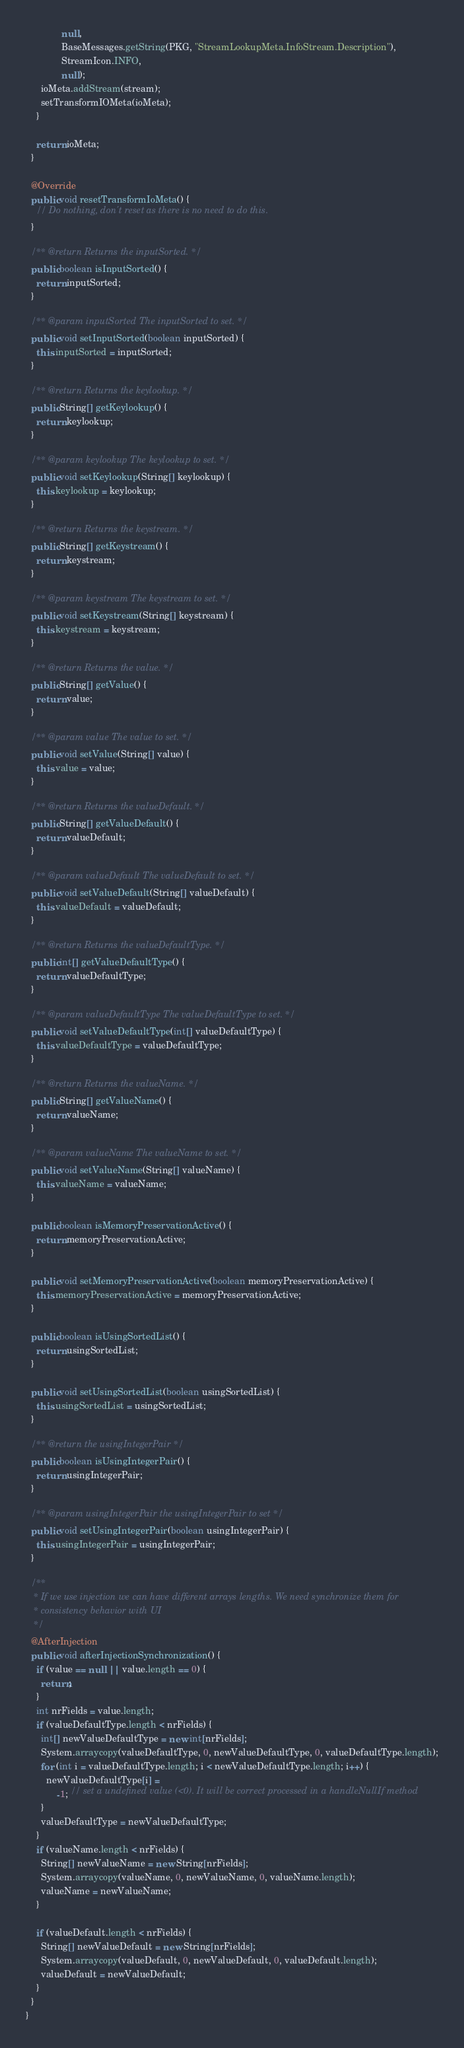<code> <loc_0><loc_0><loc_500><loc_500><_Java_>              null,
              BaseMessages.getString(PKG, "StreamLookupMeta.InfoStream.Description"),
              StreamIcon.INFO,
              null);
      ioMeta.addStream(stream);
      setTransformIOMeta(ioMeta);
    }

    return ioMeta;
  }

  @Override
  public void resetTransformIoMeta() {
    // Do nothing, don't reset as there is no need to do this.
  }

  /** @return Returns the inputSorted. */
  public boolean isInputSorted() {
    return inputSorted;
  }

  /** @param inputSorted The inputSorted to set. */
  public void setInputSorted(boolean inputSorted) {
    this.inputSorted = inputSorted;
  }

  /** @return Returns the keylookup. */
  public String[] getKeylookup() {
    return keylookup;
  }

  /** @param keylookup The keylookup to set. */
  public void setKeylookup(String[] keylookup) {
    this.keylookup = keylookup;
  }

  /** @return Returns the keystream. */
  public String[] getKeystream() {
    return keystream;
  }

  /** @param keystream The keystream to set. */
  public void setKeystream(String[] keystream) {
    this.keystream = keystream;
  }

  /** @return Returns the value. */
  public String[] getValue() {
    return value;
  }

  /** @param value The value to set. */
  public void setValue(String[] value) {
    this.value = value;
  }

  /** @return Returns the valueDefault. */
  public String[] getValueDefault() {
    return valueDefault;
  }

  /** @param valueDefault The valueDefault to set. */
  public void setValueDefault(String[] valueDefault) {
    this.valueDefault = valueDefault;
  }

  /** @return Returns the valueDefaultType. */
  public int[] getValueDefaultType() {
    return valueDefaultType;
  }

  /** @param valueDefaultType The valueDefaultType to set. */
  public void setValueDefaultType(int[] valueDefaultType) {
    this.valueDefaultType = valueDefaultType;
  }

  /** @return Returns the valueName. */
  public String[] getValueName() {
    return valueName;
  }

  /** @param valueName The valueName to set. */
  public void setValueName(String[] valueName) {
    this.valueName = valueName;
  }

  public boolean isMemoryPreservationActive() {
    return memoryPreservationActive;
  }

  public void setMemoryPreservationActive(boolean memoryPreservationActive) {
    this.memoryPreservationActive = memoryPreservationActive;
  }

  public boolean isUsingSortedList() {
    return usingSortedList;
  }

  public void setUsingSortedList(boolean usingSortedList) {
    this.usingSortedList = usingSortedList;
  }

  /** @return the usingIntegerPair */
  public boolean isUsingIntegerPair() {
    return usingIntegerPair;
  }

  /** @param usingIntegerPair the usingIntegerPair to set */
  public void setUsingIntegerPair(boolean usingIntegerPair) {
    this.usingIntegerPair = usingIntegerPair;
  }

  /**
   * If we use injection we can have different arrays lengths. We need synchronize them for
   * consistency behavior with UI
   */
  @AfterInjection
  public void afterInjectionSynchronization() {
    if (value == null || value.length == 0) {
      return;
    }
    int nrFields = value.length;
    if (valueDefaultType.length < nrFields) {
      int[] newValueDefaultType = new int[nrFields];
      System.arraycopy(valueDefaultType, 0, newValueDefaultType, 0, valueDefaultType.length);
      for (int i = valueDefaultType.length; i < newValueDefaultType.length; i++) {
        newValueDefaultType[i] =
            -1; // set a undefined value (<0). It will be correct processed in a handleNullIf method
      }
      valueDefaultType = newValueDefaultType;
    }
    if (valueName.length < nrFields) {
      String[] newValueName = new String[nrFields];
      System.arraycopy(valueName, 0, newValueName, 0, valueName.length);
      valueName = newValueName;
    }

    if (valueDefault.length < nrFields) {
      String[] newValueDefault = new String[nrFields];
      System.arraycopy(valueDefault, 0, newValueDefault, 0, valueDefault.length);
      valueDefault = newValueDefault;
    }
  }
}
</code> 